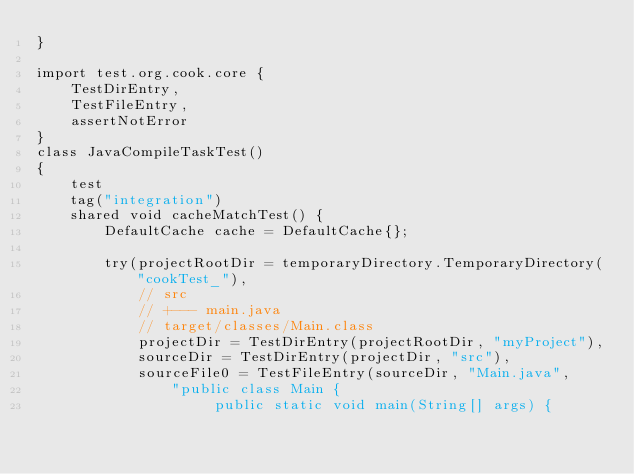Convert code to text. <code><loc_0><loc_0><loc_500><loc_500><_Ceylon_>}

import test.org.cook.core {
	TestDirEntry,
	TestFileEntry,
	assertNotError
}
class JavaCompileTaskTest() 
{
	test
	tag("integration")
	shared void cacheMatchTest() {
		DefaultCache cache = DefaultCache{}; 
		
		try(projectRootDir = temporaryDirectory.TemporaryDirectory("cookTest_"),
			// src
			// +--- main.java
			// target/classes/Main.class
			projectDir = TestDirEntry(projectRootDir, "myProject"),
			sourceDir = TestDirEntry(projectDir, "src"),
			sourceFile0 = TestFileEntry(sourceDir, "Main.java", 
				"public class Main {
				     public static void main(String[] args) {</code> 